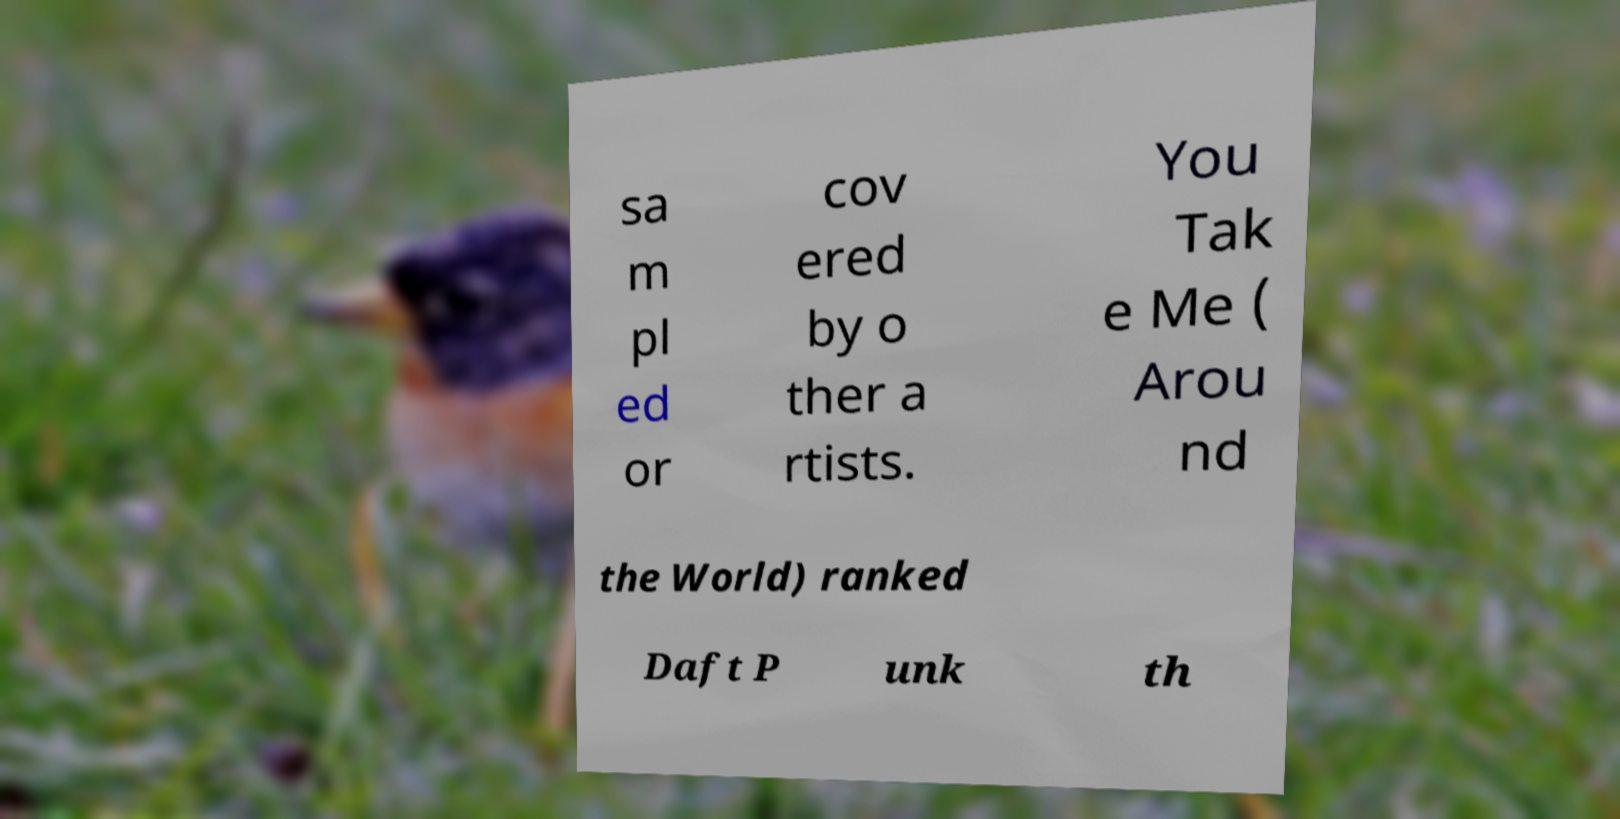Could you extract and type out the text from this image? sa m pl ed or cov ered by o ther a rtists. You Tak e Me ( Arou nd the World) ranked Daft P unk th 